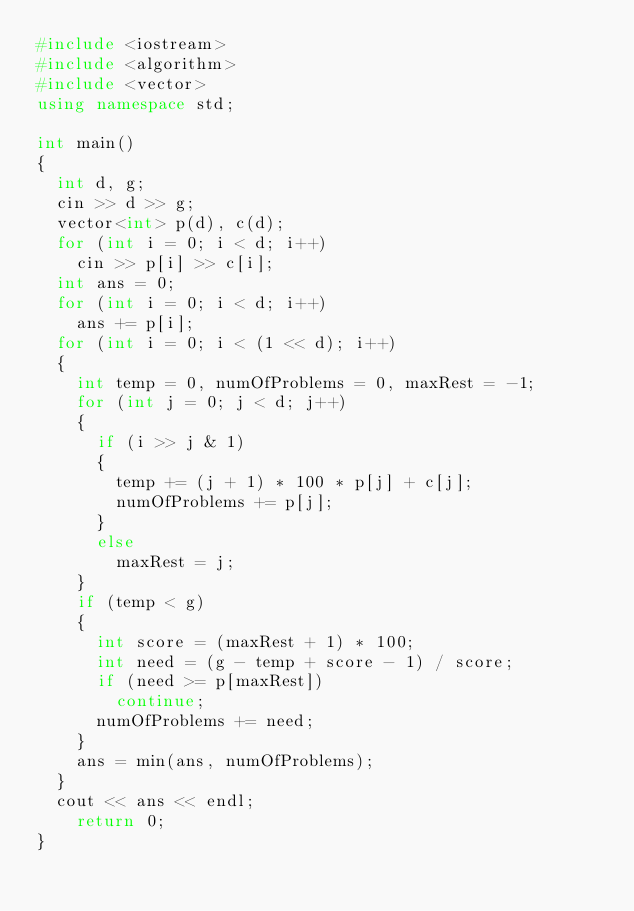<code> <loc_0><loc_0><loc_500><loc_500><_C++_>#include <iostream>
#include <algorithm>
#include <vector>
using namespace std;

int main()
{
	int d, g;
	cin >> d >> g;
	vector<int> p(d), c(d);
	for (int i = 0; i < d; i++)
		cin >> p[i] >> c[i];
	int ans = 0;
	for (int i = 0; i < d; i++)
		ans += p[i];
	for (int i = 0; i < (1 << d); i++)
	{
		int temp = 0, numOfProblems = 0, maxRest = -1;
		for (int j = 0; j < d; j++)
		{
			if (i >> j & 1)
			{
				temp += (j + 1) * 100 * p[j] + c[j];
				numOfProblems += p[j];
			}
			else
				maxRest = j;
		}
		if (temp < g)
		{
			int score = (maxRest + 1) * 100;
			int need = (g - temp + score - 1) / score;
			if (need >= p[maxRest])
				continue;
			numOfProblems += need;
		}
		ans = min(ans, numOfProblems);
	}
	cout << ans << endl;
    return 0;
}</code> 